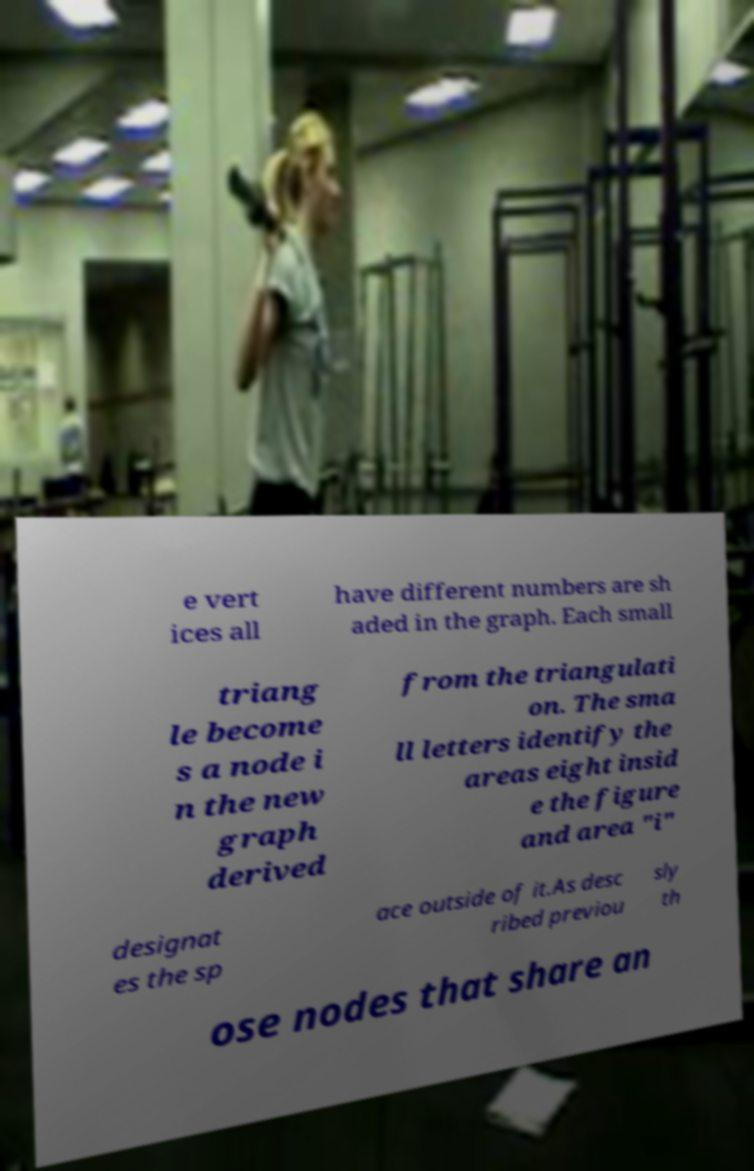There's text embedded in this image that I need extracted. Can you transcribe it verbatim? e vert ices all have different numbers are sh aded in the graph. Each small triang le become s a node i n the new graph derived from the triangulati on. The sma ll letters identify the areas eight insid e the figure and area "i" designat es the sp ace outside of it.As desc ribed previou sly th ose nodes that share an 